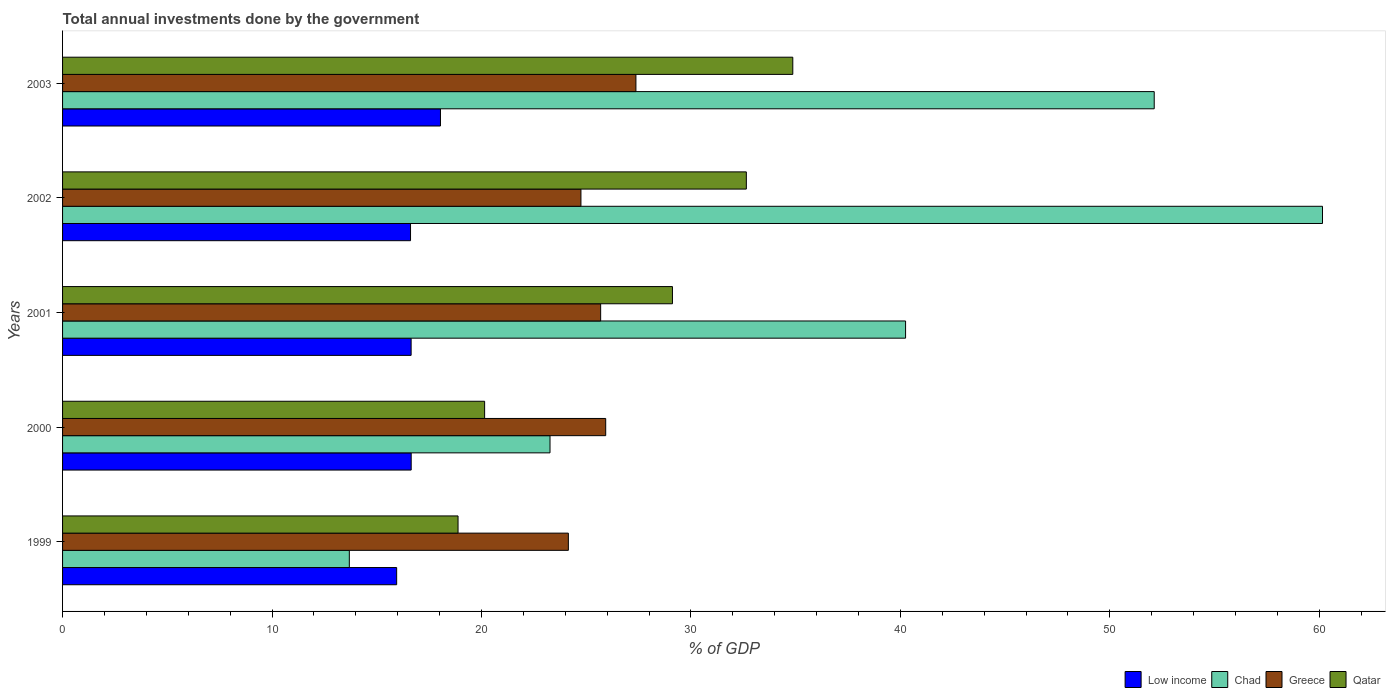How many different coloured bars are there?
Offer a very short reply. 4. How many bars are there on the 2nd tick from the bottom?
Your response must be concise. 4. What is the total annual investments done by the government in Greece in 2001?
Keep it short and to the point. 25.69. Across all years, what is the maximum total annual investments done by the government in Qatar?
Provide a short and direct response. 34.87. Across all years, what is the minimum total annual investments done by the government in Chad?
Your response must be concise. 13.69. What is the total total annual investments done by the government in Greece in the graph?
Your answer should be compact. 127.9. What is the difference between the total annual investments done by the government in Qatar in 1999 and that in 2002?
Offer a terse response. -13.76. What is the difference between the total annual investments done by the government in Qatar in 2000 and the total annual investments done by the government in Greece in 2002?
Keep it short and to the point. -4.6. What is the average total annual investments done by the government in Chad per year?
Ensure brevity in your answer.  37.9. In the year 2000, what is the difference between the total annual investments done by the government in Chad and total annual investments done by the government in Qatar?
Your answer should be very brief. 3.12. What is the ratio of the total annual investments done by the government in Chad in 1999 to that in 2002?
Make the answer very short. 0.23. What is the difference between the highest and the second highest total annual investments done by the government in Chad?
Keep it short and to the point. 8.03. What is the difference between the highest and the lowest total annual investments done by the government in Low income?
Offer a very short reply. 2.09. Is the sum of the total annual investments done by the government in Chad in 2000 and 2003 greater than the maximum total annual investments done by the government in Greece across all years?
Your response must be concise. Yes. What does the 3rd bar from the top in 1999 represents?
Offer a very short reply. Chad. What does the 1st bar from the bottom in 2002 represents?
Keep it short and to the point. Low income. Is it the case that in every year, the sum of the total annual investments done by the government in Qatar and total annual investments done by the government in Chad is greater than the total annual investments done by the government in Greece?
Offer a very short reply. Yes. What is the difference between two consecutive major ticks on the X-axis?
Your response must be concise. 10. Does the graph contain any zero values?
Your answer should be very brief. No. Does the graph contain grids?
Your answer should be very brief. No. How many legend labels are there?
Your response must be concise. 4. How are the legend labels stacked?
Provide a succinct answer. Horizontal. What is the title of the graph?
Your answer should be very brief. Total annual investments done by the government. Does "Morocco" appear as one of the legend labels in the graph?
Make the answer very short. No. What is the label or title of the X-axis?
Offer a very short reply. % of GDP. What is the % of GDP of Low income in 1999?
Make the answer very short. 15.95. What is the % of GDP in Chad in 1999?
Keep it short and to the point. 13.69. What is the % of GDP in Greece in 1999?
Your answer should be compact. 24.15. What is the % of GDP of Qatar in 1999?
Offer a very short reply. 18.88. What is the % of GDP of Low income in 2000?
Provide a short and direct response. 16.65. What is the % of GDP in Chad in 2000?
Give a very brief answer. 23.27. What is the % of GDP of Greece in 2000?
Keep it short and to the point. 25.93. What is the % of GDP of Qatar in 2000?
Provide a short and direct response. 20.15. What is the % of GDP in Low income in 2001?
Provide a succinct answer. 16.64. What is the % of GDP of Chad in 2001?
Ensure brevity in your answer.  40.25. What is the % of GDP of Greece in 2001?
Make the answer very short. 25.69. What is the % of GDP of Qatar in 2001?
Keep it short and to the point. 29.12. What is the % of GDP in Low income in 2002?
Offer a very short reply. 16.61. What is the % of GDP in Chad in 2002?
Offer a terse response. 60.16. What is the % of GDP in Greece in 2002?
Make the answer very short. 24.75. What is the % of GDP of Qatar in 2002?
Keep it short and to the point. 32.65. What is the % of GDP of Low income in 2003?
Your answer should be compact. 18.04. What is the % of GDP in Chad in 2003?
Provide a succinct answer. 52.12. What is the % of GDP of Greece in 2003?
Keep it short and to the point. 27.37. What is the % of GDP of Qatar in 2003?
Provide a succinct answer. 34.87. Across all years, what is the maximum % of GDP of Low income?
Provide a succinct answer. 18.04. Across all years, what is the maximum % of GDP in Chad?
Provide a short and direct response. 60.16. Across all years, what is the maximum % of GDP in Greece?
Offer a terse response. 27.37. Across all years, what is the maximum % of GDP of Qatar?
Provide a succinct answer. 34.87. Across all years, what is the minimum % of GDP in Low income?
Offer a terse response. 15.95. Across all years, what is the minimum % of GDP of Chad?
Provide a short and direct response. 13.69. Across all years, what is the minimum % of GDP of Greece?
Provide a short and direct response. 24.15. Across all years, what is the minimum % of GDP of Qatar?
Give a very brief answer. 18.88. What is the total % of GDP in Low income in the graph?
Your answer should be very brief. 83.9. What is the total % of GDP in Chad in the graph?
Ensure brevity in your answer.  189.49. What is the total % of GDP in Greece in the graph?
Provide a succinct answer. 127.9. What is the total % of GDP in Qatar in the graph?
Keep it short and to the point. 135.67. What is the difference between the % of GDP in Low income in 1999 and that in 2000?
Provide a succinct answer. -0.69. What is the difference between the % of GDP in Chad in 1999 and that in 2000?
Your answer should be very brief. -9.58. What is the difference between the % of GDP of Greece in 1999 and that in 2000?
Give a very brief answer. -1.78. What is the difference between the % of GDP of Qatar in 1999 and that in 2000?
Provide a short and direct response. -1.27. What is the difference between the % of GDP in Low income in 1999 and that in 2001?
Provide a succinct answer. -0.69. What is the difference between the % of GDP of Chad in 1999 and that in 2001?
Offer a terse response. -26.56. What is the difference between the % of GDP of Greece in 1999 and that in 2001?
Provide a succinct answer. -1.54. What is the difference between the % of GDP of Qatar in 1999 and that in 2001?
Offer a terse response. -10.24. What is the difference between the % of GDP of Low income in 1999 and that in 2002?
Provide a succinct answer. -0.66. What is the difference between the % of GDP of Chad in 1999 and that in 2002?
Your answer should be very brief. -46.46. What is the difference between the % of GDP in Qatar in 1999 and that in 2002?
Keep it short and to the point. -13.76. What is the difference between the % of GDP of Low income in 1999 and that in 2003?
Provide a succinct answer. -2.09. What is the difference between the % of GDP in Chad in 1999 and that in 2003?
Keep it short and to the point. -38.43. What is the difference between the % of GDP in Greece in 1999 and that in 2003?
Provide a succinct answer. -3.23. What is the difference between the % of GDP of Qatar in 1999 and that in 2003?
Give a very brief answer. -15.98. What is the difference between the % of GDP of Low income in 2000 and that in 2001?
Keep it short and to the point. 0. What is the difference between the % of GDP in Chad in 2000 and that in 2001?
Give a very brief answer. -16.98. What is the difference between the % of GDP in Greece in 2000 and that in 2001?
Your response must be concise. 0.24. What is the difference between the % of GDP in Qatar in 2000 and that in 2001?
Your response must be concise. -8.97. What is the difference between the % of GDP of Low income in 2000 and that in 2002?
Your response must be concise. 0.03. What is the difference between the % of GDP in Chad in 2000 and that in 2002?
Your answer should be very brief. -36.88. What is the difference between the % of GDP in Greece in 2000 and that in 2002?
Provide a short and direct response. 1.18. What is the difference between the % of GDP of Qatar in 2000 and that in 2002?
Ensure brevity in your answer.  -12.5. What is the difference between the % of GDP in Low income in 2000 and that in 2003?
Ensure brevity in your answer.  -1.4. What is the difference between the % of GDP of Chad in 2000 and that in 2003?
Provide a succinct answer. -28.85. What is the difference between the % of GDP of Greece in 2000 and that in 2003?
Your answer should be compact. -1.44. What is the difference between the % of GDP of Qatar in 2000 and that in 2003?
Ensure brevity in your answer.  -14.71. What is the difference between the % of GDP in Low income in 2001 and that in 2002?
Ensure brevity in your answer.  0.03. What is the difference between the % of GDP in Chad in 2001 and that in 2002?
Give a very brief answer. -19.91. What is the difference between the % of GDP of Greece in 2001 and that in 2002?
Offer a terse response. 0.94. What is the difference between the % of GDP in Qatar in 2001 and that in 2002?
Ensure brevity in your answer.  -3.53. What is the difference between the % of GDP in Low income in 2001 and that in 2003?
Your response must be concise. -1.4. What is the difference between the % of GDP of Chad in 2001 and that in 2003?
Ensure brevity in your answer.  -11.87. What is the difference between the % of GDP of Greece in 2001 and that in 2003?
Keep it short and to the point. -1.68. What is the difference between the % of GDP in Qatar in 2001 and that in 2003?
Your response must be concise. -5.75. What is the difference between the % of GDP in Low income in 2002 and that in 2003?
Give a very brief answer. -1.43. What is the difference between the % of GDP of Chad in 2002 and that in 2003?
Offer a very short reply. 8.03. What is the difference between the % of GDP of Greece in 2002 and that in 2003?
Provide a short and direct response. -2.63. What is the difference between the % of GDP in Qatar in 2002 and that in 2003?
Provide a short and direct response. -2.22. What is the difference between the % of GDP of Low income in 1999 and the % of GDP of Chad in 2000?
Provide a short and direct response. -7.32. What is the difference between the % of GDP of Low income in 1999 and the % of GDP of Greece in 2000?
Keep it short and to the point. -9.98. What is the difference between the % of GDP of Low income in 1999 and the % of GDP of Qatar in 2000?
Provide a succinct answer. -4.2. What is the difference between the % of GDP of Chad in 1999 and the % of GDP of Greece in 2000?
Ensure brevity in your answer.  -12.24. What is the difference between the % of GDP in Chad in 1999 and the % of GDP in Qatar in 2000?
Offer a very short reply. -6.46. What is the difference between the % of GDP of Greece in 1999 and the % of GDP of Qatar in 2000?
Provide a succinct answer. 4. What is the difference between the % of GDP in Low income in 1999 and the % of GDP in Chad in 2001?
Provide a succinct answer. -24.3. What is the difference between the % of GDP of Low income in 1999 and the % of GDP of Greece in 2001?
Give a very brief answer. -9.74. What is the difference between the % of GDP of Low income in 1999 and the % of GDP of Qatar in 2001?
Keep it short and to the point. -13.17. What is the difference between the % of GDP of Chad in 1999 and the % of GDP of Greece in 2001?
Your answer should be very brief. -12. What is the difference between the % of GDP of Chad in 1999 and the % of GDP of Qatar in 2001?
Your answer should be compact. -15.43. What is the difference between the % of GDP in Greece in 1999 and the % of GDP in Qatar in 2001?
Make the answer very short. -4.97. What is the difference between the % of GDP in Low income in 1999 and the % of GDP in Chad in 2002?
Ensure brevity in your answer.  -44.2. What is the difference between the % of GDP of Low income in 1999 and the % of GDP of Greece in 2002?
Ensure brevity in your answer.  -8.8. What is the difference between the % of GDP in Low income in 1999 and the % of GDP in Qatar in 2002?
Your response must be concise. -16.7. What is the difference between the % of GDP in Chad in 1999 and the % of GDP in Greece in 2002?
Provide a short and direct response. -11.06. What is the difference between the % of GDP in Chad in 1999 and the % of GDP in Qatar in 2002?
Offer a very short reply. -18.96. What is the difference between the % of GDP in Greece in 1999 and the % of GDP in Qatar in 2002?
Provide a succinct answer. -8.5. What is the difference between the % of GDP of Low income in 1999 and the % of GDP of Chad in 2003?
Keep it short and to the point. -36.17. What is the difference between the % of GDP in Low income in 1999 and the % of GDP in Greece in 2003?
Keep it short and to the point. -11.42. What is the difference between the % of GDP of Low income in 1999 and the % of GDP of Qatar in 2003?
Offer a very short reply. -18.91. What is the difference between the % of GDP in Chad in 1999 and the % of GDP in Greece in 2003?
Your response must be concise. -13.68. What is the difference between the % of GDP of Chad in 1999 and the % of GDP of Qatar in 2003?
Provide a short and direct response. -21.17. What is the difference between the % of GDP in Greece in 1999 and the % of GDP in Qatar in 2003?
Your answer should be compact. -10.72. What is the difference between the % of GDP in Low income in 2000 and the % of GDP in Chad in 2001?
Offer a terse response. -23.6. What is the difference between the % of GDP of Low income in 2000 and the % of GDP of Greece in 2001?
Give a very brief answer. -9.05. What is the difference between the % of GDP in Low income in 2000 and the % of GDP in Qatar in 2001?
Make the answer very short. -12.47. What is the difference between the % of GDP of Chad in 2000 and the % of GDP of Greece in 2001?
Your response must be concise. -2.42. What is the difference between the % of GDP in Chad in 2000 and the % of GDP in Qatar in 2001?
Ensure brevity in your answer.  -5.85. What is the difference between the % of GDP of Greece in 2000 and the % of GDP of Qatar in 2001?
Offer a terse response. -3.19. What is the difference between the % of GDP of Low income in 2000 and the % of GDP of Chad in 2002?
Make the answer very short. -43.51. What is the difference between the % of GDP in Low income in 2000 and the % of GDP in Greece in 2002?
Your answer should be very brief. -8.1. What is the difference between the % of GDP in Low income in 2000 and the % of GDP in Qatar in 2002?
Offer a terse response. -16. What is the difference between the % of GDP of Chad in 2000 and the % of GDP of Greece in 2002?
Make the answer very short. -1.48. What is the difference between the % of GDP in Chad in 2000 and the % of GDP in Qatar in 2002?
Give a very brief answer. -9.37. What is the difference between the % of GDP of Greece in 2000 and the % of GDP of Qatar in 2002?
Your response must be concise. -6.71. What is the difference between the % of GDP in Low income in 2000 and the % of GDP in Chad in 2003?
Provide a short and direct response. -35.48. What is the difference between the % of GDP in Low income in 2000 and the % of GDP in Greece in 2003?
Your response must be concise. -10.73. What is the difference between the % of GDP in Low income in 2000 and the % of GDP in Qatar in 2003?
Your answer should be compact. -18.22. What is the difference between the % of GDP of Chad in 2000 and the % of GDP of Greece in 2003?
Offer a terse response. -4.1. What is the difference between the % of GDP in Chad in 2000 and the % of GDP in Qatar in 2003?
Give a very brief answer. -11.59. What is the difference between the % of GDP in Greece in 2000 and the % of GDP in Qatar in 2003?
Provide a succinct answer. -8.93. What is the difference between the % of GDP of Low income in 2001 and the % of GDP of Chad in 2002?
Your response must be concise. -43.51. What is the difference between the % of GDP of Low income in 2001 and the % of GDP of Greece in 2002?
Provide a short and direct response. -8.11. What is the difference between the % of GDP of Low income in 2001 and the % of GDP of Qatar in 2002?
Your answer should be very brief. -16.01. What is the difference between the % of GDP in Chad in 2001 and the % of GDP in Greece in 2002?
Make the answer very short. 15.5. What is the difference between the % of GDP of Chad in 2001 and the % of GDP of Qatar in 2002?
Provide a succinct answer. 7.6. What is the difference between the % of GDP of Greece in 2001 and the % of GDP of Qatar in 2002?
Provide a succinct answer. -6.96. What is the difference between the % of GDP of Low income in 2001 and the % of GDP of Chad in 2003?
Make the answer very short. -35.48. What is the difference between the % of GDP of Low income in 2001 and the % of GDP of Greece in 2003?
Keep it short and to the point. -10.73. What is the difference between the % of GDP of Low income in 2001 and the % of GDP of Qatar in 2003?
Your response must be concise. -18.22. What is the difference between the % of GDP in Chad in 2001 and the % of GDP in Greece in 2003?
Make the answer very short. 12.88. What is the difference between the % of GDP in Chad in 2001 and the % of GDP in Qatar in 2003?
Make the answer very short. 5.38. What is the difference between the % of GDP of Greece in 2001 and the % of GDP of Qatar in 2003?
Provide a short and direct response. -9.17. What is the difference between the % of GDP of Low income in 2002 and the % of GDP of Chad in 2003?
Offer a very short reply. -35.51. What is the difference between the % of GDP in Low income in 2002 and the % of GDP in Greece in 2003?
Your answer should be compact. -10.76. What is the difference between the % of GDP of Low income in 2002 and the % of GDP of Qatar in 2003?
Offer a very short reply. -18.25. What is the difference between the % of GDP of Chad in 2002 and the % of GDP of Greece in 2003?
Offer a very short reply. 32.78. What is the difference between the % of GDP in Chad in 2002 and the % of GDP in Qatar in 2003?
Your answer should be very brief. 25.29. What is the difference between the % of GDP in Greece in 2002 and the % of GDP in Qatar in 2003?
Keep it short and to the point. -10.12. What is the average % of GDP in Low income per year?
Ensure brevity in your answer.  16.78. What is the average % of GDP of Chad per year?
Ensure brevity in your answer.  37.9. What is the average % of GDP of Greece per year?
Offer a terse response. 25.58. What is the average % of GDP in Qatar per year?
Your answer should be very brief. 27.13. In the year 1999, what is the difference between the % of GDP in Low income and % of GDP in Chad?
Offer a very short reply. 2.26. In the year 1999, what is the difference between the % of GDP in Low income and % of GDP in Greece?
Give a very brief answer. -8.2. In the year 1999, what is the difference between the % of GDP of Low income and % of GDP of Qatar?
Provide a succinct answer. -2.93. In the year 1999, what is the difference between the % of GDP in Chad and % of GDP in Greece?
Your response must be concise. -10.46. In the year 1999, what is the difference between the % of GDP in Chad and % of GDP in Qatar?
Provide a short and direct response. -5.19. In the year 1999, what is the difference between the % of GDP of Greece and % of GDP of Qatar?
Your answer should be very brief. 5.27. In the year 2000, what is the difference between the % of GDP of Low income and % of GDP of Chad?
Ensure brevity in your answer.  -6.63. In the year 2000, what is the difference between the % of GDP in Low income and % of GDP in Greece?
Provide a succinct answer. -9.29. In the year 2000, what is the difference between the % of GDP of Low income and % of GDP of Qatar?
Ensure brevity in your answer.  -3.51. In the year 2000, what is the difference between the % of GDP in Chad and % of GDP in Greece?
Give a very brief answer. -2.66. In the year 2000, what is the difference between the % of GDP of Chad and % of GDP of Qatar?
Make the answer very short. 3.12. In the year 2000, what is the difference between the % of GDP of Greece and % of GDP of Qatar?
Provide a short and direct response. 5.78. In the year 2001, what is the difference between the % of GDP in Low income and % of GDP in Chad?
Give a very brief answer. -23.61. In the year 2001, what is the difference between the % of GDP of Low income and % of GDP of Greece?
Offer a terse response. -9.05. In the year 2001, what is the difference between the % of GDP of Low income and % of GDP of Qatar?
Make the answer very short. -12.48. In the year 2001, what is the difference between the % of GDP in Chad and % of GDP in Greece?
Offer a very short reply. 14.56. In the year 2001, what is the difference between the % of GDP in Chad and % of GDP in Qatar?
Keep it short and to the point. 11.13. In the year 2001, what is the difference between the % of GDP in Greece and % of GDP in Qatar?
Offer a terse response. -3.43. In the year 2002, what is the difference between the % of GDP of Low income and % of GDP of Chad?
Keep it short and to the point. -43.54. In the year 2002, what is the difference between the % of GDP of Low income and % of GDP of Greece?
Ensure brevity in your answer.  -8.14. In the year 2002, what is the difference between the % of GDP in Low income and % of GDP in Qatar?
Provide a succinct answer. -16.03. In the year 2002, what is the difference between the % of GDP in Chad and % of GDP in Greece?
Your response must be concise. 35.41. In the year 2002, what is the difference between the % of GDP of Chad and % of GDP of Qatar?
Provide a short and direct response. 27.51. In the year 2002, what is the difference between the % of GDP of Greece and % of GDP of Qatar?
Provide a succinct answer. -7.9. In the year 2003, what is the difference between the % of GDP in Low income and % of GDP in Chad?
Your response must be concise. -34.08. In the year 2003, what is the difference between the % of GDP in Low income and % of GDP in Greece?
Provide a short and direct response. -9.33. In the year 2003, what is the difference between the % of GDP of Low income and % of GDP of Qatar?
Provide a short and direct response. -16.82. In the year 2003, what is the difference between the % of GDP in Chad and % of GDP in Greece?
Offer a very short reply. 24.75. In the year 2003, what is the difference between the % of GDP in Chad and % of GDP in Qatar?
Make the answer very short. 17.26. In the year 2003, what is the difference between the % of GDP in Greece and % of GDP in Qatar?
Give a very brief answer. -7.49. What is the ratio of the % of GDP of Low income in 1999 to that in 2000?
Offer a terse response. 0.96. What is the ratio of the % of GDP of Chad in 1999 to that in 2000?
Provide a short and direct response. 0.59. What is the ratio of the % of GDP of Greece in 1999 to that in 2000?
Make the answer very short. 0.93. What is the ratio of the % of GDP in Qatar in 1999 to that in 2000?
Offer a terse response. 0.94. What is the ratio of the % of GDP of Low income in 1999 to that in 2001?
Provide a succinct answer. 0.96. What is the ratio of the % of GDP of Chad in 1999 to that in 2001?
Offer a very short reply. 0.34. What is the ratio of the % of GDP of Greece in 1999 to that in 2001?
Offer a very short reply. 0.94. What is the ratio of the % of GDP of Qatar in 1999 to that in 2001?
Ensure brevity in your answer.  0.65. What is the ratio of the % of GDP in Low income in 1999 to that in 2002?
Provide a succinct answer. 0.96. What is the ratio of the % of GDP of Chad in 1999 to that in 2002?
Make the answer very short. 0.23. What is the ratio of the % of GDP in Greece in 1999 to that in 2002?
Offer a very short reply. 0.98. What is the ratio of the % of GDP of Qatar in 1999 to that in 2002?
Your answer should be compact. 0.58. What is the ratio of the % of GDP of Low income in 1999 to that in 2003?
Give a very brief answer. 0.88. What is the ratio of the % of GDP of Chad in 1999 to that in 2003?
Keep it short and to the point. 0.26. What is the ratio of the % of GDP of Greece in 1999 to that in 2003?
Offer a terse response. 0.88. What is the ratio of the % of GDP in Qatar in 1999 to that in 2003?
Your response must be concise. 0.54. What is the ratio of the % of GDP in Low income in 2000 to that in 2001?
Provide a succinct answer. 1. What is the ratio of the % of GDP in Chad in 2000 to that in 2001?
Your answer should be very brief. 0.58. What is the ratio of the % of GDP of Greece in 2000 to that in 2001?
Provide a succinct answer. 1.01. What is the ratio of the % of GDP of Qatar in 2000 to that in 2001?
Provide a short and direct response. 0.69. What is the ratio of the % of GDP in Low income in 2000 to that in 2002?
Your response must be concise. 1. What is the ratio of the % of GDP in Chad in 2000 to that in 2002?
Your response must be concise. 0.39. What is the ratio of the % of GDP in Greece in 2000 to that in 2002?
Offer a terse response. 1.05. What is the ratio of the % of GDP of Qatar in 2000 to that in 2002?
Give a very brief answer. 0.62. What is the ratio of the % of GDP of Low income in 2000 to that in 2003?
Offer a terse response. 0.92. What is the ratio of the % of GDP in Chad in 2000 to that in 2003?
Your response must be concise. 0.45. What is the ratio of the % of GDP in Greece in 2000 to that in 2003?
Ensure brevity in your answer.  0.95. What is the ratio of the % of GDP in Qatar in 2000 to that in 2003?
Keep it short and to the point. 0.58. What is the ratio of the % of GDP in Chad in 2001 to that in 2002?
Provide a succinct answer. 0.67. What is the ratio of the % of GDP in Greece in 2001 to that in 2002?
Give a very brief answer. 1.04. What is the ratio of the % of GDP of Qatar in 2001 to that in 2002?
Make the answer very short. 0.89. What is the ratio of the % of GDP of Low income in 2001 to that in 2003?
Keep it short and to the point. 0.92. What is the ratio of the % of GDP in Chad in 2001 to that in 2003?
Give a very brief answer. 0.77. What is the ratio of the % of GDP of Greece in 2001 to that in 2003?
Offer a terse response. 0.94. What is the ratio of the % of GDP in Qatar in 2001 to that in 2003?
Make the answer very short. 0.84. What is the ratio of the % of GDP of Low income in 2002 to that in 2003?
Offer a very short reply. 0.92. What is the ratio of the % of GDP in Chad in 2002 to that in 2003?
Offer a terse response. 1.15. What is the ratio of the % of GDP in Greece in 2002 to that in 2003?
Offer a very short reply. 0.9. What is the ratio of the % of GDP of Qatar in 2002 to that in 2003?
Your answer should be very brief. 0.94. What is the difference between the highest and the second highest % of GDP of Low income?
Your answer should be compact. 1.4. What is the difference between the highest and the second highest % of GDP in Chad?
Offer a very short reply. 8.03. What is the difference between the highest and the second highest % of GDP of Greece?
Make the answer very short. 1.44. What is the difference between the highest and the second highest % of GDP in Qatar?
Keep it short and to the point. 2.22. What is the difference between the highest and the lowest % of GDP in Low income?
Keep it short and to the point. 2.09. What is the difference between the highest and the lowest % of GDP in Chad?
Your answer should be very brief. 46.46. What is the difference between the highest and the lowest % of GDP in Greece?
Your response must be concise. 3.23. What is the difference between the highest and the lowest % of GDP of Qatar?
Provide a short and direct response. 15.98. 